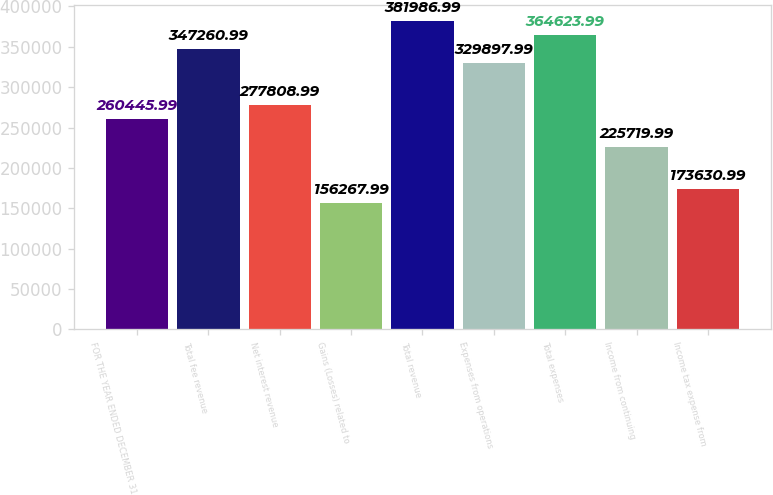Convert chart to OTSL. <chart><loc_0><loc_0><loc_500><loc_500><bar_chart><fcel>FOR THE YEAR ENDED DECEMBER 31<fcel>Total fee revenue<fcel>Net interest revenue<fcel>Gains (Losses) related to<fcel>Total revenue<fcel>Expenses from operations<fcel>Total expenses<fcel>Income from continuing<fcel>Income tax expense from<nl><fcel>260446<fcel>347261<fcel>277809<fcel>156268<fcel>381987<fcel>329898<fcel>364624<fcel>225720<fcel>173631<nl></chart> 